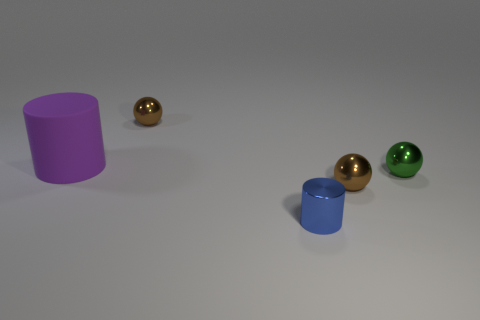What can you infer about the setting of these objects? It appears to be a neutral, non-descript setting with even lighting, perhaps a studio setup for showcasing the objects without any distractions. 